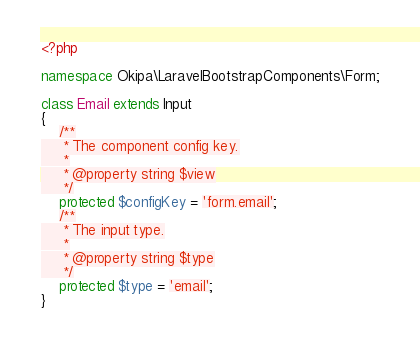<code> <loc_0><loc_0><loc_500><loc_500><_PHP_><?php

namespace Okipa\LaravelBootstrapComponents\Form;

class Email extends Input
{
    /**
     * The component config key.
     *
     * @property string $view
     */
    protected $configKey = 'form.email';
    /**
     * The input type.
     *
     * @property string $type
     */
    protected $type = 'email';
}
</code> 